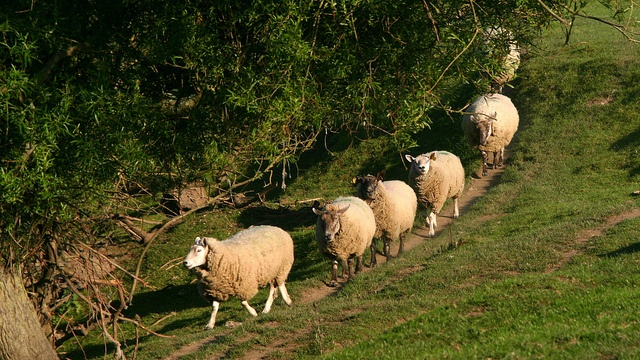Describe the objects in this image and their specific colors. I can see sheep in black and tan tones, sheep in black, tan, and olive tones, sheep in black and tan tones, sheep in black, tan, and maroon tones, and sheep in black and tan tones in this image. 